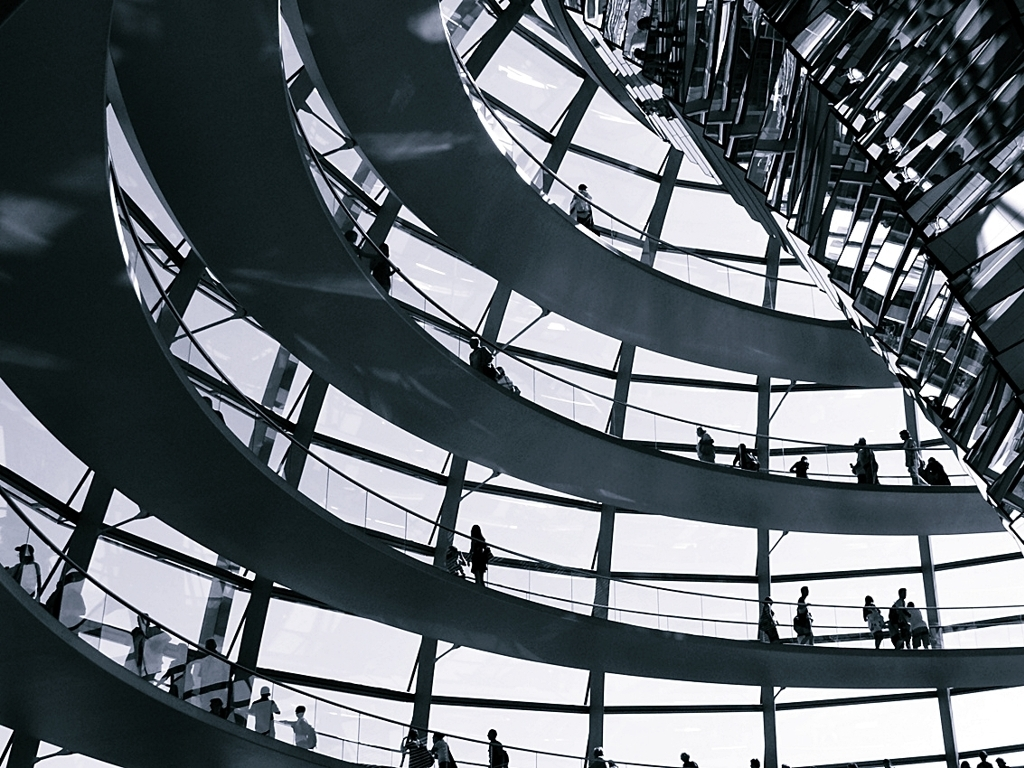What architectural style is reflected in the image? The image showcases a modern architectural style with a strong focus on sleek, curvilinear forms and the extensive use of glass, creating a sense of openness and fluidity within the structure. 